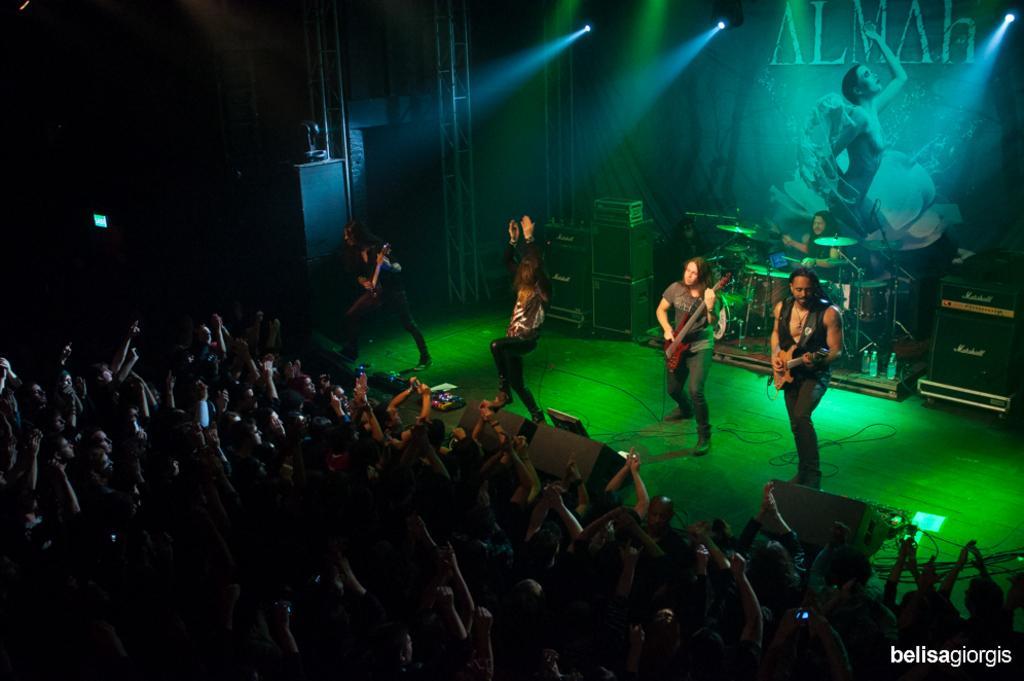Can you describe this image briefly? At the bottom of the image there are people. To the right side of the image there are people playing musical instruments. There is a poster. There are lights. There are speakers. At the bottom of the image there is text. 